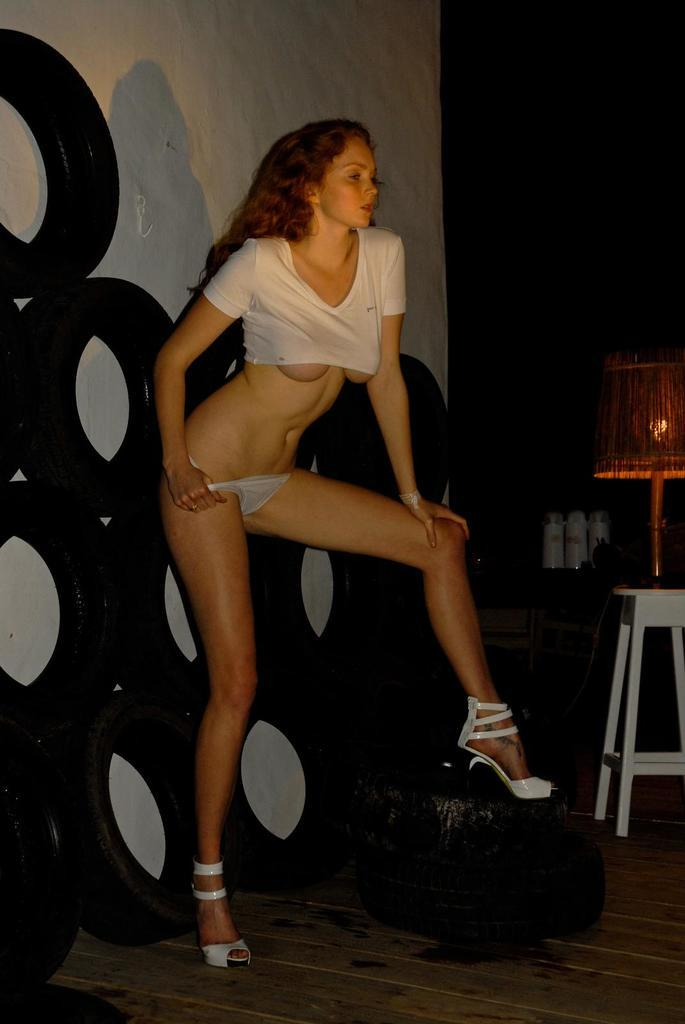Who is present in the image? There is a woman in the image. What is the woman doing in the image? The woman is standing. What objects can be seen behind the woman? There are tires behind the woman. What objects can be seen on the right side of the image? There is a lamp and a stool on the right side of the image. What type of fork can be seen in the woman's hand in the image? There is no fork present in the image; the woman is not holding anything in her hand. 